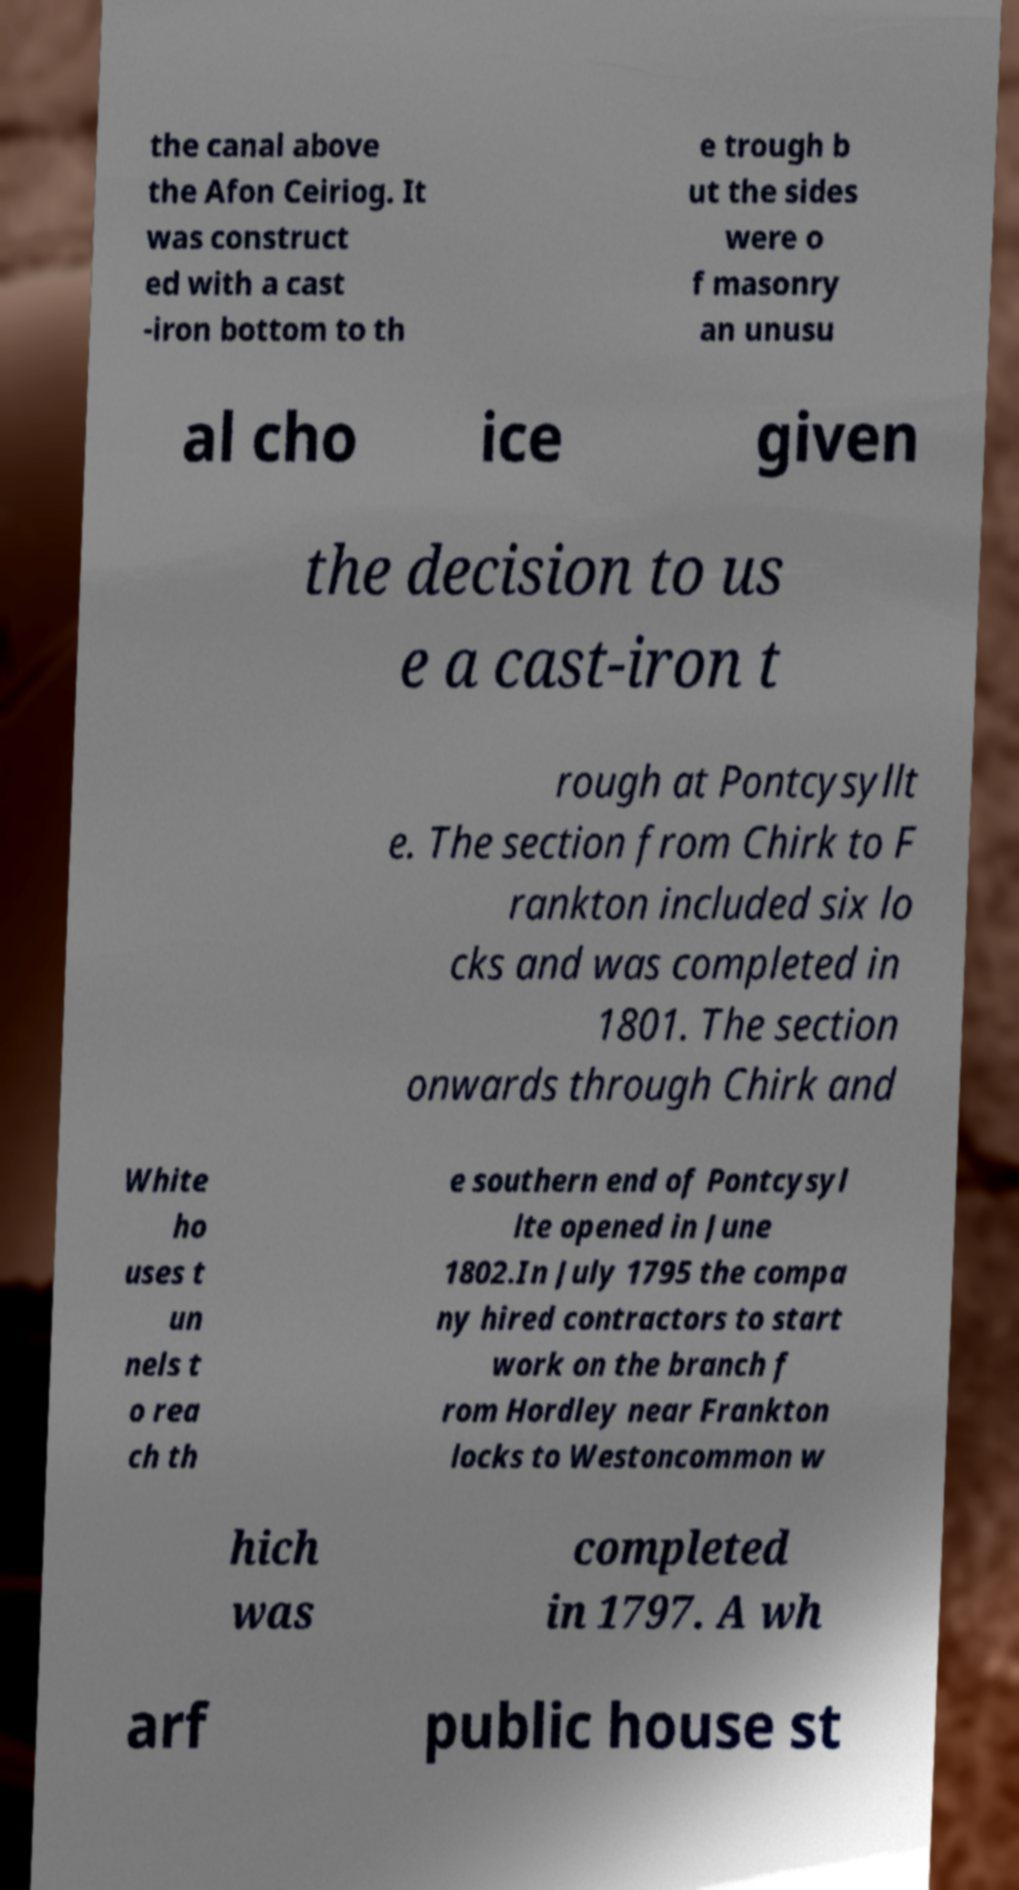For documentation purposes, I need the text within this image transcribed. Could you provide that? the canal above the Afon Ceiriog. It was construct ed with a cast -iron bottom to th e trough b ut the sides were o f masonry an unusu al cho ice given the decision to us e a cast-iron t rough at Pontcysyllt e. The section from Chirk to F rankton included six lo cks and was completed in 1801. The section onwards through Chirk and White ho uses t un nels t o rea ch th e southern end of Pontcysyl lte opened in June 1802.In July 1795 the compa ny hired contractors to start work on the branch f rom Hordley near Frankton locks to Westoncommon w hich was completed in 1797. A wh arf public house st 